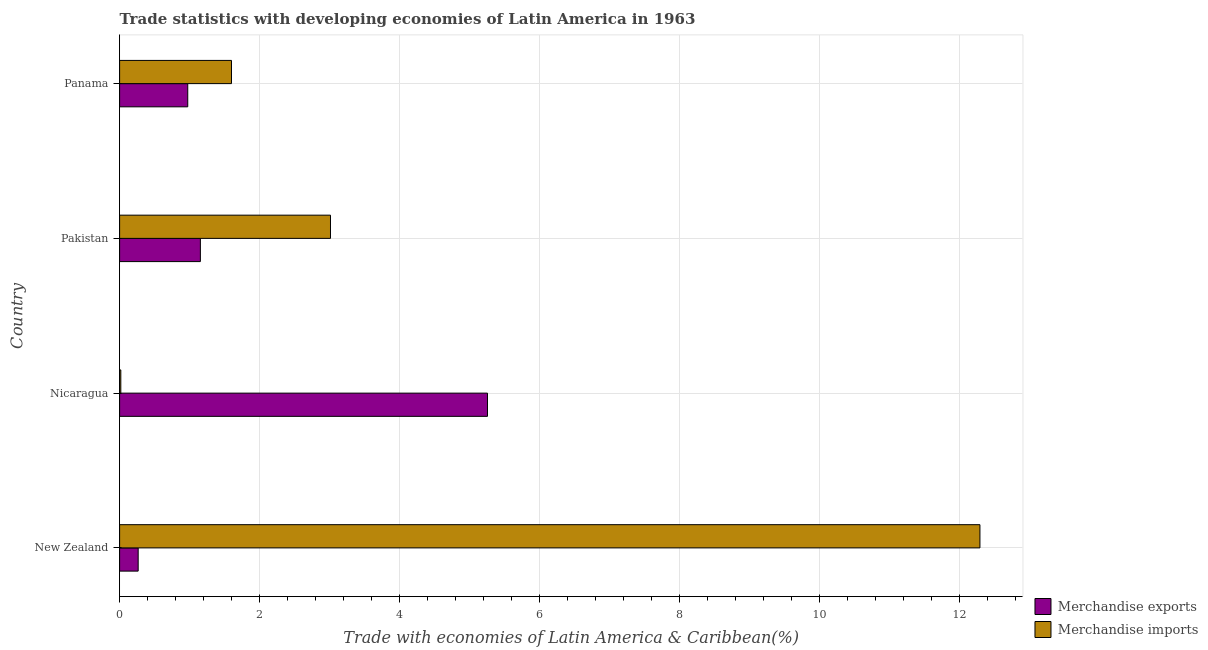How many different coloured bars are there?
Make the answer very short. 2. Are the number of bars on each tick of the Y-axis equal?
Offer a very short reply. Yes. How many bars are there on the 3rd tick from the bottom?
Provide a succinct answer. 2. In how many cases, is the number of bars for a given country not equal to the number of legend labels?
Offer a very short reply. 0. What is the merchandise imports in Panama?
Your response must be concise. 1.6. Across all countries, what is the maximum merchandise exports?
Your answer should be very brief. 5.25. Across all countries, what is the minimum merchandise exports?
Offer a terse response. 0.27. In which country was the merchandise imports maximum?
Ensure brevity in your answer.  New Zealand. In which country was the merchandise exports minimum?
Provide a succinct answer. New Zealand. What is the total merchandise exports in the graph?
Offer a very short reply. 7.65. What is the difference between the merchandise imports in Pakistan and that in Panama?
Your answer should be compact. 1.41. What is the difference between the merchandise exports in Panama and the merchandise imports in Nicaragua?
Provide a short and direct response. 0.96. What is the average merchandise imports per country?
Make the answer very short. 4.23. What is the difference between the merchandise exports and merchandise imports in Pakistan?
Give a very brief answer. -1.86. In how many countries, is the merchandise exports greater than 6.4 %?
Your response must be concise. 0. What is the ratio of the merchandise imports in New Zealand to that in Pakistan?
Give a very brief answer. 4.08. Is the difference between the merchandise imports in New Zealand and Panama greater than the difference between the merchandise exports in New Zealand and Panama?
Provide a succinct answer. Yes. What is the difference between the highest and the lowest merchandise exports?
Make the answer very short. 4.99. In how many countries, is the merchandise imports greater than the average merchandise imports taken over all countries?
Make the answer very short. 1. What does the 1st bar from the top in Nicaragua represents?
Give a very brief answer. Merchandise imports. Are all the bars in the graph horizontal?
Give a very brief answer. Yes. Does the graph contain any zero values?
Your response must be concise. No. Where does the legend appear in the graph?
Offer a terse response. Bottom right. How are the legend labels stacked?
Your answer should be compact. Vertical. What is the title of the graph?
Your response must be concise. Trade statistics with developing economies of Latin America in 1963. What is the label or title of the X-axis?
Ensure brevity in your answer.  Trade with economies of Latin America & Caribbean(%). What is the label or title of the Y-axis?
Provide a short and direct response. Country. What is the Trade with economies of Latin America & Caribbean(%) in Merchandise exports in New Zealand?
Your answer should be compact. 0.27. What is the Trade with economies of Latin America & Caribbean(%) in Merchandise imports in New Zealand?
Give a very brief answer. 12.29. What is the Trade with economies of Latin America & Caribbean(%) in Merchandise exports in Nicaragua?
Your answer should be compact. 5.25. What is the Trade with economies of Latin America & Caribbean(%) of Merchandise imports in Nicaragua?
Your answer should be compact. 0.02. What is the Trade with economies of Latin America & Caribbean(%) in Merchandise exports in Pakistan?
Your response must be concise. 1.15. What is the Trade with economies of Latin America & Caribbean(%) in Merchandise imports in Pakistan?
Your response must be concise. 3.01. What is the Trade with economies of Latin America & Caribbean(%) in Merchandise exports in Panama?
Provide a short and direct response. 0.97. What is the Trade with economies of Latin America & Caribbean(%) in Merchandise imports in Panama?
Offer a terse response. 1.6. Across all countries, what is the maximum Trade with economies of Latin America & Caribbean(%) of Merchandise exports?
Make the answer very short. 5.25. Across all countries, what is the maximum Trade with economies of Latin America & Caribbean(%) in Merchandise imports?
Ensure brevity in your answer.  12.29. Across all countries, what is the minimum Trade with economies of Latin America & Caribbean(%) in Merchandise exports?
Your answer should be very brief. 0.27. Across all countries, what is the minimum Trade with economies of Latin America & Caribbean(%) in Merchandise imports?
Your answer should be very brief. 0.02. What is the total Trade with economies of Latin America & Caribbean(%) in Merchandise exports in the graph?
Your answer should be compact. 7.65. What is the total Trade with economies of Latin America & Caribbean(%) of Merchandise imports in the graph?
Provide a short and direct response. 16.91. What is the difference between the Trade with economies of Latin America & Caribbean(%) of Merchandise exports in New Zealand and that in Nicaragua?
Keep it short and to the point. -4.99. What is the difference between the Trade with economies of Latin America & Caribbean(%) in Merchandise imports in New Zealand and that in Nicaragua?
Your response must be concise. 12.27. What is the difference between the Trade with economies of Latin America & Caribbean(%) in Merchandise exports in New Zealand and that in Pakistan?
Keep it short and to the point. -0.89. What is the difference between the Trade with economies of Latin America & Caribbean(%) in Merchandise imports in New Zealand and that in Pakistan?
Give a very brief answer. 9.27. What is the difference between the Trade with economies of Latin America & Caribbean(%) of Merchandise exports in New Zealand and that in Panama?
Provide a short and direct response. -0.71. What is the difference between the Trade with economies of Latin America & Caribbean(%) of Merchandise imports in New Zealand and that in Panama?
Your response must be concise. 10.69. What is the difference between the Trade with economies of Latin America & Caribbean(%) in Merchandise exports in Nicaragua and that in Pakistan?
Keep it short and to the point. 4.1. What is the difference between the Trade with economies of Latin America & Caribbean(%) in Merchandise imports in Nicaragua and that in Pakistan?
Your response must be concise. -2.99. What is the difference between the Trade with economies of Latin America & Caribbean(%) of Merchandise exports in Nicaragua and that in Panama?
Give a very brief answer. 4.28. What is the difference between the Trade with economies of Latin America & Caribbean(%) of Merchandise imports in Nicaragua and that in Panama?
Your answer should be compact. -1.58. What is the difference between the Trade with economies of Latin America & Caribbean(%) in Merchandise exports in Pakistan and that in Panama?
Offer a very short reply. 0.18. What is the difference between the Trade with economies of Latin America & Caribbean(%) of Merchandise imports in Pakistan and that in Panama?
Provide a short and direct response. 1.41. What is the difference between the Trade with economies of Latin America & Caribbean(%) in Merchandise exports in New Zealand and the Trade with economies of Latin America & Caribbean(%) in Merchandise imports in Nicaragua?
Make the answer very short. 0.25. What is the difference between the Trade with economies of Latin America & Caribbean(%) of Merchandise exports in New Zealand and the Trade with economies of Latin America & Caribbean(%) of Merchandise imports in Pakistan?
Your answer should be very brief. -2.75. What is the difference between the Trade with economies of Latin America & Caribbean(%) of Merchandise exports in New Zealand and the Trade with economies of Latin America & Caribbean(%) of Merchandise imports in Panama?
Provide a succinct answer. -1.33. What is the difference between the Trade with economies of Latin America & Caribbean(%) of Merchandise exports in Nicaragua and the Trade with economies of Latin America & Caribbean(%) of Merchandise imports in Pakistan?
Keep it short and to the point. 2.24. What is the difference between the Trade with economies of Latin America & Caribbean(%) in Merchandise exports in Nicaragua and the Trade with economies of Latin America & Caribbean(%) in Merchandise imports in Panama?
Provide a succinct answer. 3.66. What is the difference between the Trade with economies of Latin America & Caribbean(%) in Merchandise exports in Pakistan and the Trade with economies of Latin America & Caribbean(%) in Merchandise imports in Panama?
Keep it short and to the point. -0.44. What is the average Trade with economies of Latin America & Caribbean(%) in Merchandise exports per country?
Provide a short and direct response. 1.91. What is the average Trade with economies of Latin America & Caribbean(%) in Merchandise imports per country?
Offer a very short reply. 4.23. What is the difference between the Trade with economies of Latin America & Caribbean(%) of Merchandise exports and Trade with economies of Latin America & Caribbean(%) of Merchandise imports in New Zealand?
Provide a short and direct response. -12.02. What is the difference between the Trade with economies of Latin America & Caribbean(%) in Merchandise exports and Trade with economies of Latin America & Caribbean(%) in Merchandise imports in Nicaragua?
Keep it short and to the point. 5.24. What is the difference between the Trade with economies of Latin America & Caribbean(%) in Merchandise exports and Trade with economies of Latin America & Caribbean(%) in Merchandise imports in Pakistan?
Provide a succinct answer. -1.86. What is the difference between the Trade with economies of Latin America & Caribbean(%) of Merchandise exports and Trade with economies of Latin America & Caribbean(%) of Merchandise imports in Panama?
Offer a very short reply. -0.62. What is the ratio of the Trade with economies of Latin America & Caribbean(%) in Merchandise exports in New Zealand to that in Nicaragua?
Ensure brevity in your answer.  0.05. What is the ratio of the Trade with economies of Latin America & Caribbean(%) of Merchandise imports in New Zealand to that in Nicaragua?
Keep it short and to the point. 712.68. What is the ratio of the Trade with economies of Latin America & Caribbean(%) in Merchandise exports in New Zealand to that in Pakistan?
Your answer should be compact. 0.23. What is the ratio of the Trade with economies of Latin America & Caribbean(%) in Merchandise imports in New Zealand to that in Pakistan?
Your response must be concise. 4.08. What is the ratio of the Trade with economies of Latin America & Caribbean(%) in Merchandise exports in New Zealand to that in Panama?
Offer a very short reply. 0.27. What is the ratio of the Trade with economies of Latin America & Caribbean(%) in Merchandise imports in New Zealand to that in Panama?
Give a very brief answer. 7.69. What is the ratio of the Trade with economies of Latin America & Caribbean(%) in Merchandise exports in Nicaragua to that in Pakistan?
Your response must be concise. 4.55. What is the ratio of the Trade with economies of Latin America & Caribbean(%) in Merchandise imports in Nicaragua to that in Pakistan?
Keep it short and to the point. 0.01. What is the ratio of the Trade with economies of Latin America & Caribbean(%) of Merchandise exports in Nicaragua to that in Panama?
Ensure brevity in your answer.  5.4. What is the ratio of the Trade with economies of Latin America & Caribbean(%) in Merchandise imports in Nicaragua to that in Panama?
Keep it short and to the point. 0.01. What is the ratio of the Trade with economies of Latin America & Caribbean(%) of Merchandise exports in Pakistan to that in Panama?
Your answer should be very brief. 1.19. What is the ratio of the Trade with economies of Latin America & Caribbean(%) in Merchandise imports in Pakistan to that in Panama?
Provide a succinct answer. 1.88. What is the difference between the highest and the second highest Trade with economies of Latin America & Caribbean(%) in Merchandise exports?
Your response must be concise. 4.1. What is the difference between the highest and the second highest Trade with economies of Latin America & Caribbean(%) in Merchandise imports?
Ensure brevity in your answer.  9.27. What is the difference between the highest and the lowest Trade with economies of Latin America & Caribbean(%) in Merchandise exports?
Provide a short and direct response. 4.99. What is the difference between the highest and the lowest Trade with economies of Latin America & Caribbean(%) in Merchandise imports?
Make the answer very short. 12.27. 